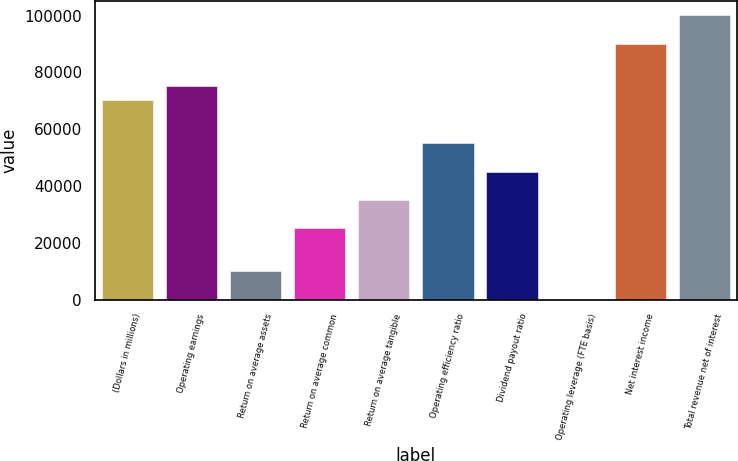Convert chart to OTSL. <chart><loc_0><loc_0><loc_500><loc_500><bar_chart><fcel>(Dollars in millions)<fcel>Operating earnings<fcel>Return on average assets<fcel>Return on average common<fcel>Return on average tangible<fcel>Operating efficiency ratio<fcel>Dividend payout ratio<fcel>Operating leverage (FTE basis)<fcel>Net interest income<fcel>Total revenue net of interest<nl><fcel>70127.2<fcel>75136.3<fcel>10018.5<fcel>25045.7<fcel>35063.8<fcel>55100.1<fcel>45081.9<fcel>0.41<fcel>90163.5<fcel>100182<nl></chart> 